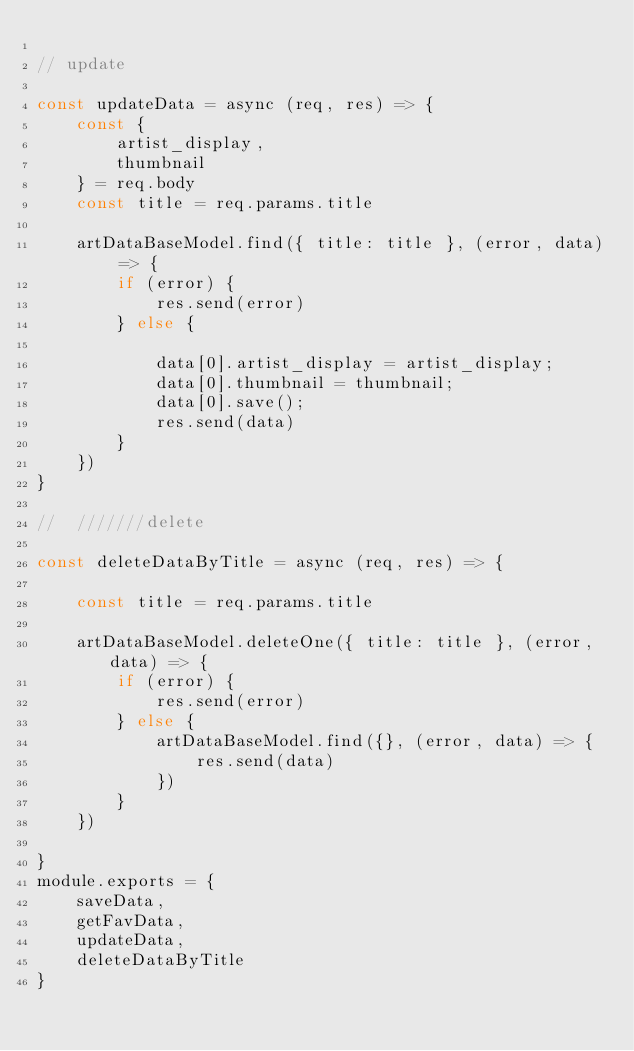<code> <loc_0><loc_0><loc_500><loc_500><_JavaScript_>
// update

const updateData = async (req, res) => {
    const {
        artist_display,
        thumbnail
    } = req.body
    const title = req.params.title

    artDataBaseModel.find({ title: title }, (error, data) => {
        if (error) {
            res.send(error)
        } else {

            data[0].artist_display = artist_display;
            data[0].thumbnail = thumbnail;
            data[0].save();
            res.send(data)
        }
    })
}

//  ///////delete 

const deleteDataByTitle = async (req, res) => {

    const title = req.params.title

    artDataBaseModel.deleteOne({ title: title }, (error, data) => {
        if (error) {
            res.send(error)
        } else {
            artDataBaseModel.find({}, (error, data) => {
                res.send(data)
            })
        }
    })

}
module.exports = {
    saveData,
    getFavData,
    updateData,
    deleteDataByTitle
}
</code> 